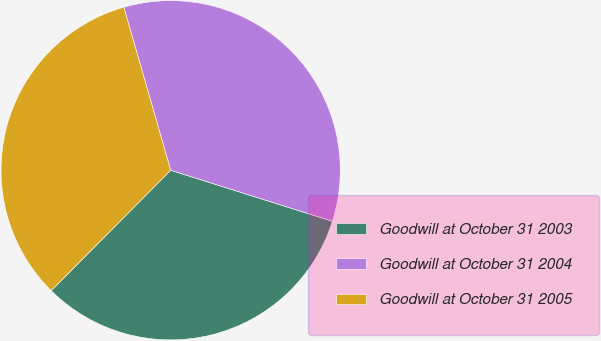Convert chart. <chart><loc_0><loc_0><loc_500><loc_500><pie_chart><fcel>Goodwill at October 31 2003<fcel>Goodwill at October 31 2004<fcel>Goodwill at October 31 2005<nl><fcel>32.57%<fcel>34.32%<fcel>33.11%<nl></chart> 